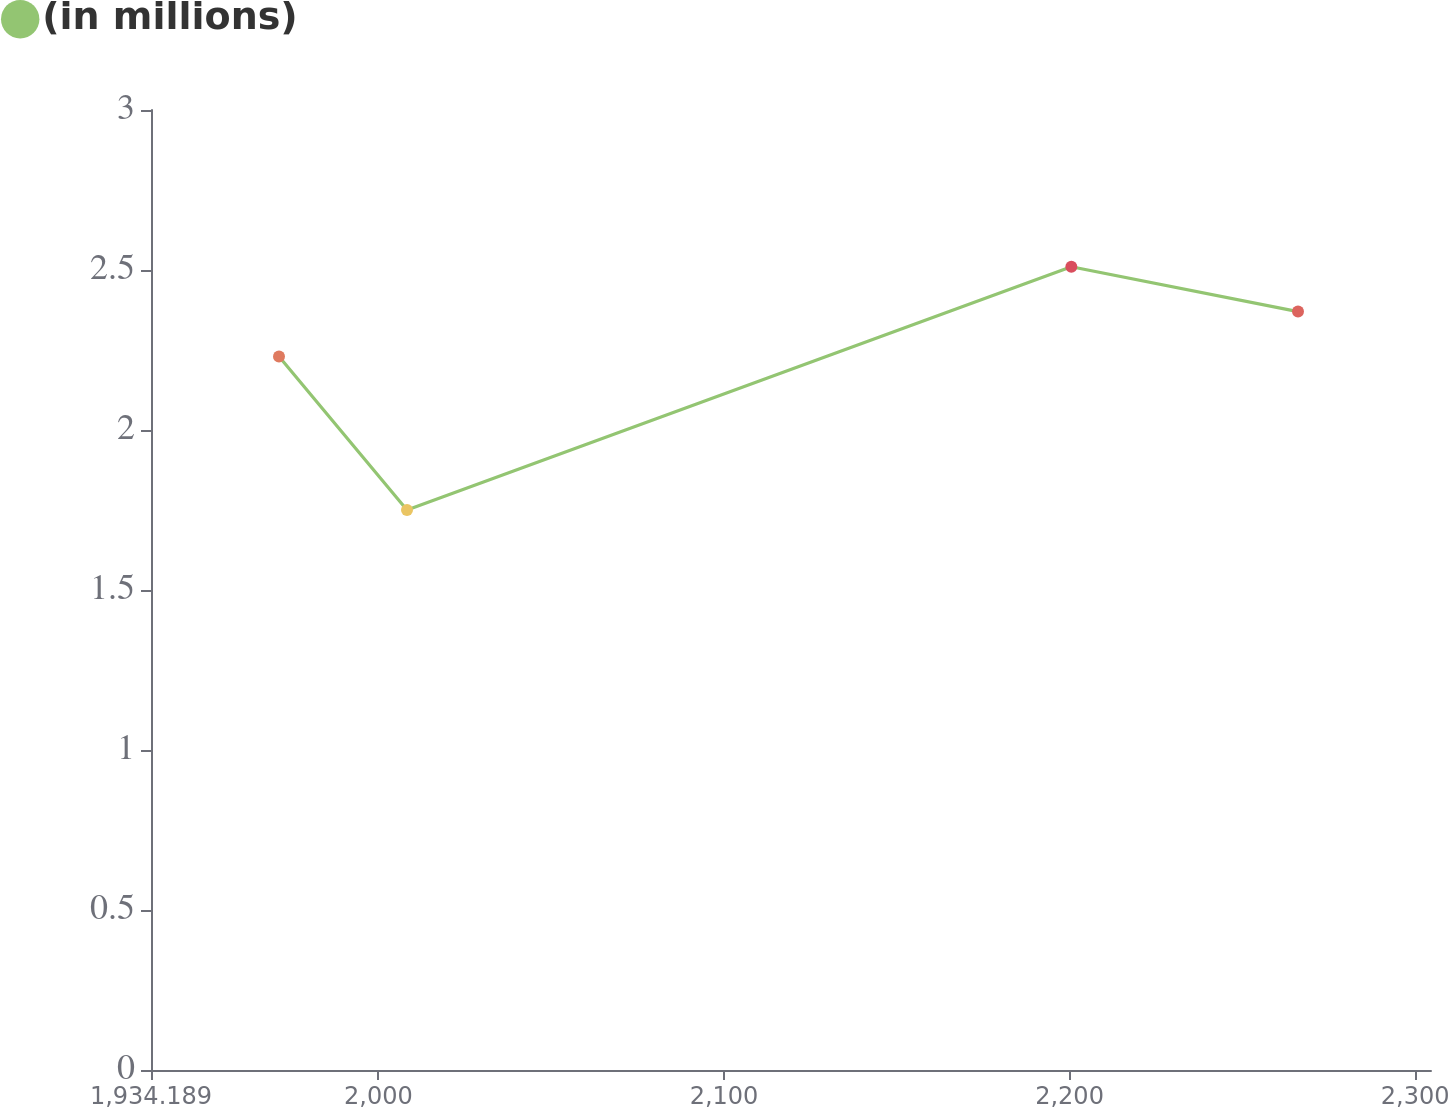Convert chart. <chart><loc_0><loc_0><loc_500><loc_500><line_chart><ecel><fcel>(in millions)<nl><fcel>1971.23<fcel>2.23<nl><fcel>2008.27<fcel>1.75<nl><fcel>2200.52<fcel>2.51<nl><fcel>2266.11<fcel>2.37<nl><fcel>2341.64<fcel>0.96<nl></chart> 